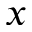Convert formula to latex. <formula><loc_0><loc_0><loc_500><loc_500>x</formula> 